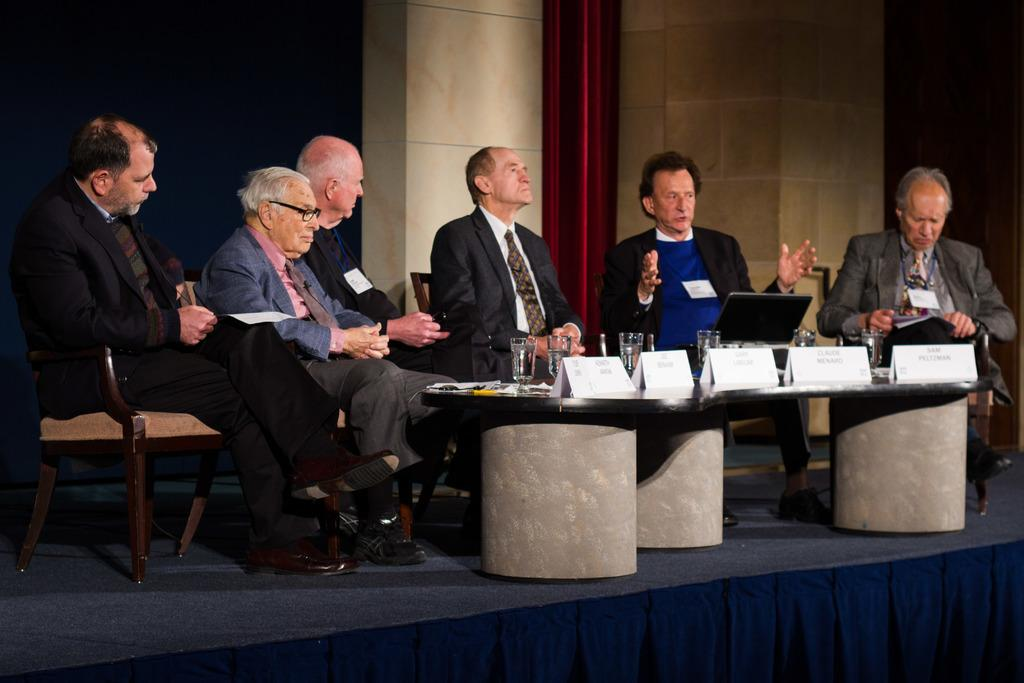What are the members in the image doing? There is a group of members sitting on chairs. What objects are on the table in the image? There are glasses and a board on the table. What can be seen in the background of the image? There is a wall and a curtain in the background. What type of weather can be seen through the window in the image? There is no window present in the image, so it is not possible to determine the weather. 